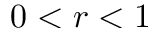Convert formula to latex. <formula><loc_0><loc_0><loc_500><loc_500>0 < r < 1</formula> 